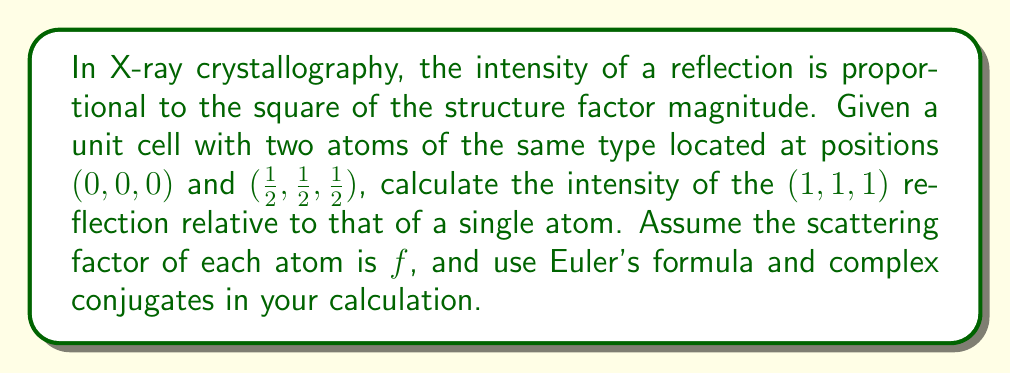Solve this math problem. To solve this problem, we'll follow these steps:

1) First, recall that the structure factor $F_{hkl}$ for a unit cell with $N$ atoms is given by:

   $$F_{hkl} = \sum_{j=1}^{N} f_j e^{2\pi i (hx_j + ky_j + lz_j)}$$

   where $(x_j, y_j, z_j)$ are the fractional coordinates of the $j$-th atom.

2) For our case, we have two atoms with the same scattering factor $f$:
   - Atom 1 at $(0,0,0)$
   - Atom 2 at $(1/2,1/2,1/2)$

3) Let's calculate the structure factor for the $(1,1,1)$ reflection:

   $$F_{111} = f e^{2\pi i (1\cdot0 + 1\cdot0 + 1\cdot0)} + f e^{2\pi i (1\cdot1/2 + 1\cdot1/2 + 1\cdot1/2)}$$

4) Simplify:
   $$F_{111} = f (1 + e^{\pi i})$$

5) Using Euler's formula, $e^{\pi i} = -1$, we get:
   $$F_{111} = f (1 - 1) = 0$$

6) The intensity $I$ is proportional to the square of the magnitude of the structure factor:
   $$I \propto |F_{111}|^2$$

7) To calculate $|F_{111}|^2$, we multiply $F_{111}$ by its complex conjugate:
   $$|F_{111}|^2 = F_{111} \cdot F_{111}^* = 0 \cdot 0 = 0$$

8) The intensity of a single atom would be proportional to $|f|^2$.

9) Therefore, the relative intensity of the $(1,1,1)$ reflection compared to a single atom is:
   $$\frac{I_{111}}{I_{single}} = \frac{|F_{111}|^2}{|f|^2} = \frac{0}{|f|^2} = 0$$
Answer: The intensity of the $(1,1,1)$ reflection relative to that of a single atom is 0. 